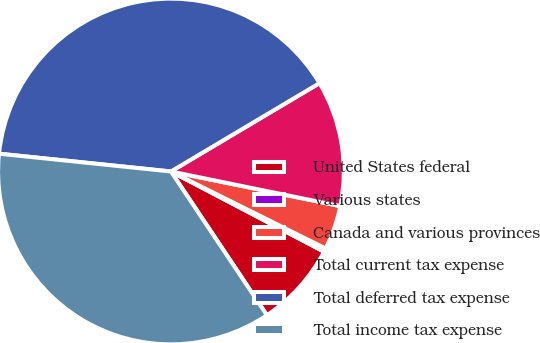Convert chart. <chart><loc_0><loc_0><loc_500><loc_500><pie_chart><fcel>United States federal<fcel>Various states<fcel>Canada and various provinces<fcel>Total current tax expense<fcel>Total deferred tax expense<fcel>Total income tax expense<nl><fcel>7.95%<fcel>0.33%<fcel>4.14%<fcel>11.75%<fcel>39.82%<fcel>36.01%<nl></chart> 